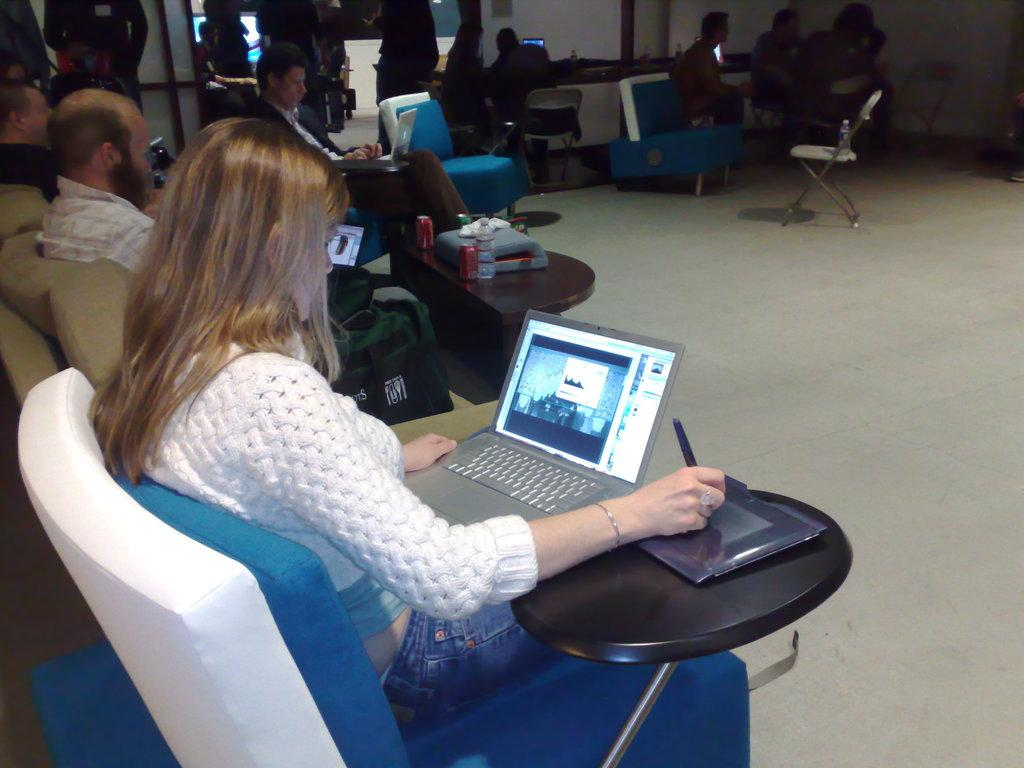What are the people in the image doing? There are persons sitting on chairs in the image. What is one person specifically focused on? One person is looking at a laptop. What piece of furniture is present in the image? There is a table in the image. What items can be seen on the table? There are bottles on the table. How many chairs are visible in the image? There is at least one chair in the image. What type of rings can be seen on the person's fingers in the image? There is no mention of rings or any jewelry in the image; the focus is on the persons sitting on chairs and the laptop. 